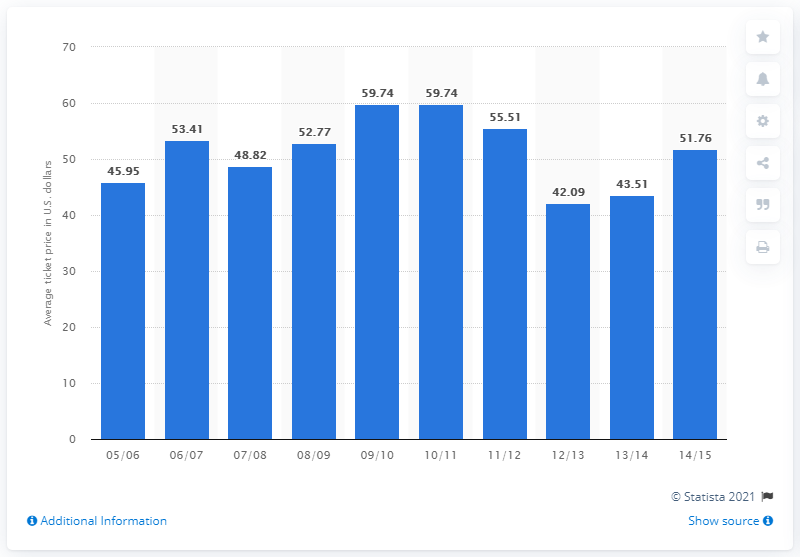Identify some key points in this picture. The average ticket price in the 2005/06 season was 45.95. 